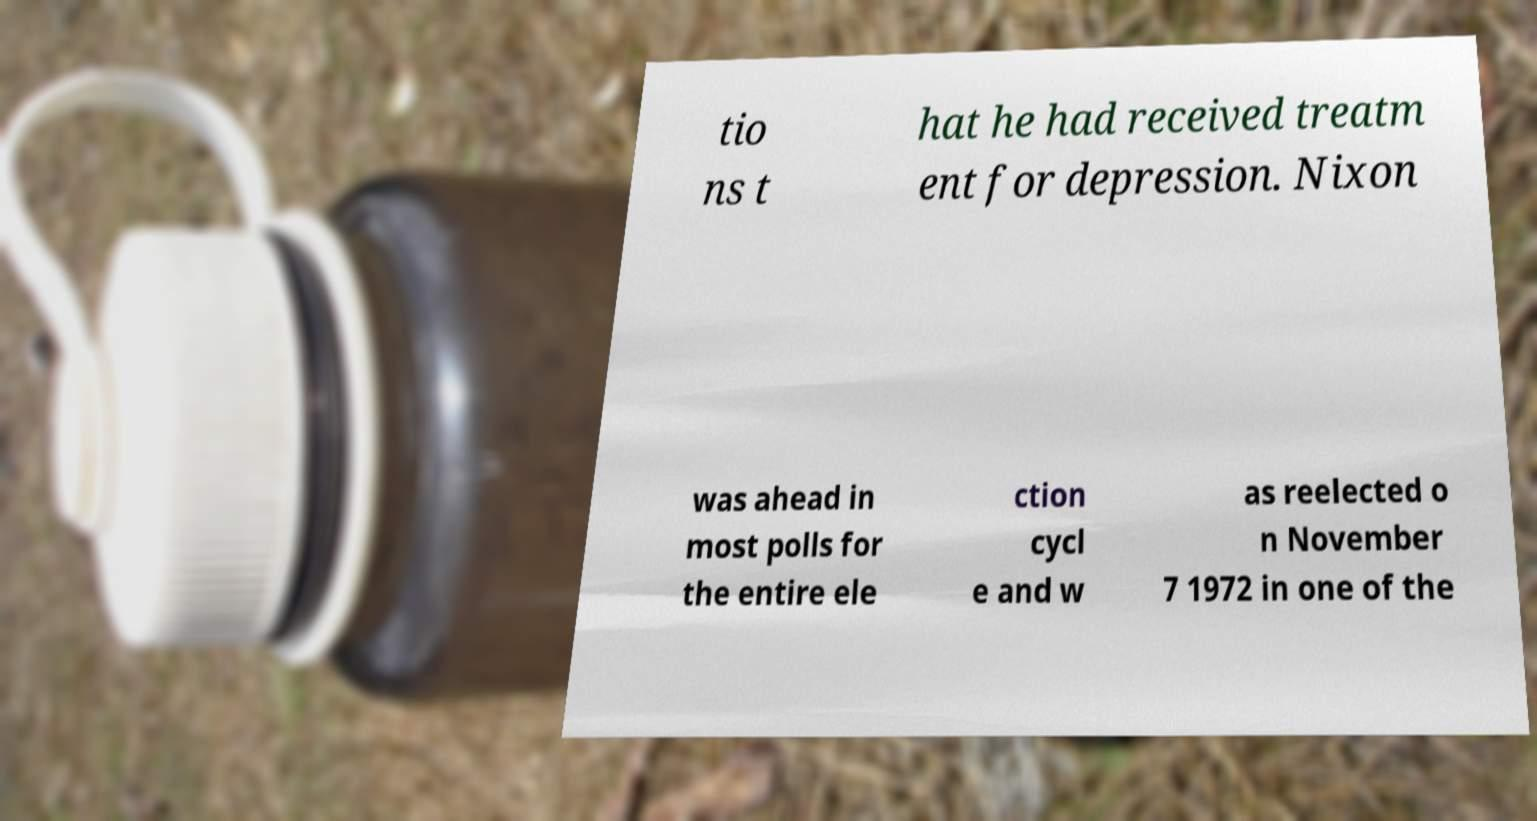What messages or text are displayed in this image? I need them in a readable, typed format. tio ns t hat he had received treatm ent for depression. Nixon was ahead in most polls for the entire ele ction cycl e and w as reelected o n November 7 1972 in one of the 